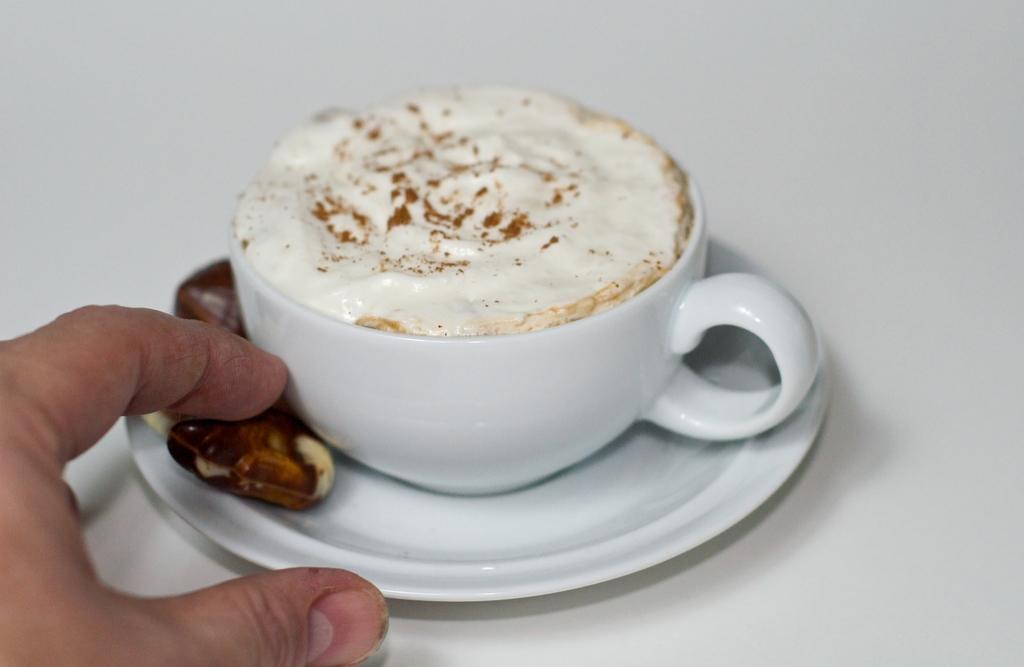Please provide a concise description of this image. In this picture, we can see a person hand and a saucer and on the saucer there is a cup with a coffee and other food. 